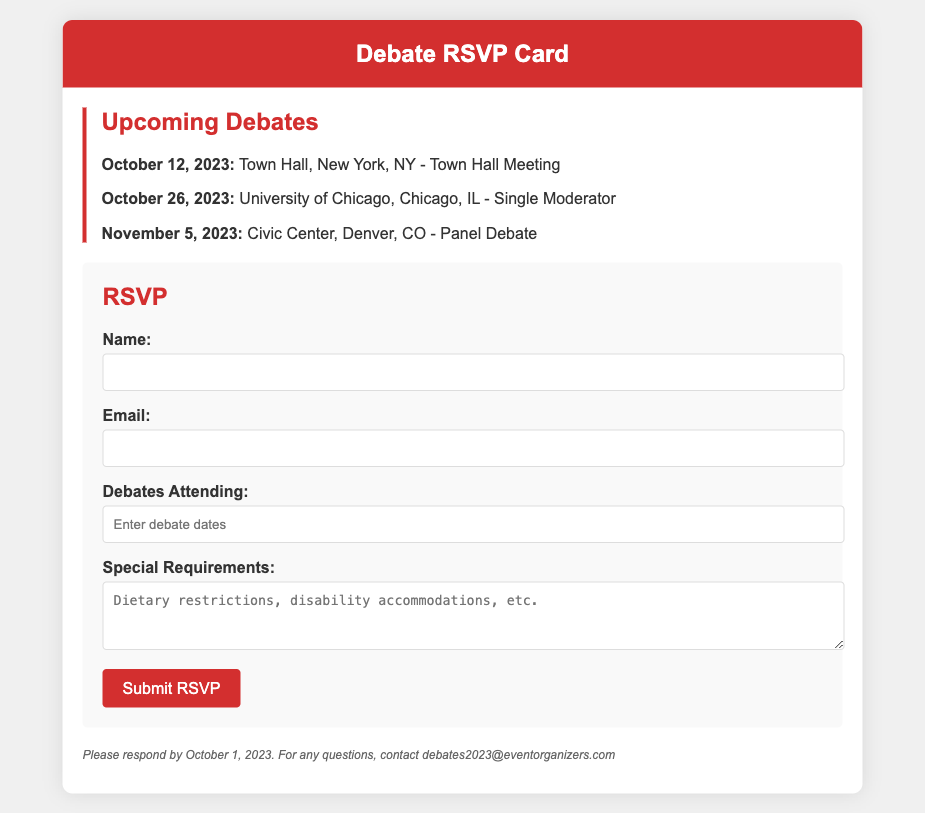what is the date of the first debate? The first debate is scheduled for October 12, 2023, as mentioned in the document.
Answer: October 12, 2023 where is the second debate taking place? The second debate will be held at the University of Chicago, as indicated in the document.
Answer: University of Chicago what type of debate is scheduled for November 5, 2023? The document specifies that the debate on November 5, 2023, is a Panel Debate.
Answer: Panel Debate how many days are there between the first and the last debate? The last debate is on November 5, 2023, and the first is on October 12, 2023; calculating the days in between gives a total of 24 days.
Answer: 24 days what is the RSVP deadline mentioned in the document? The document states that the RSVP must be submitted by October 1, 2023.
Answer: October 1, 2023 